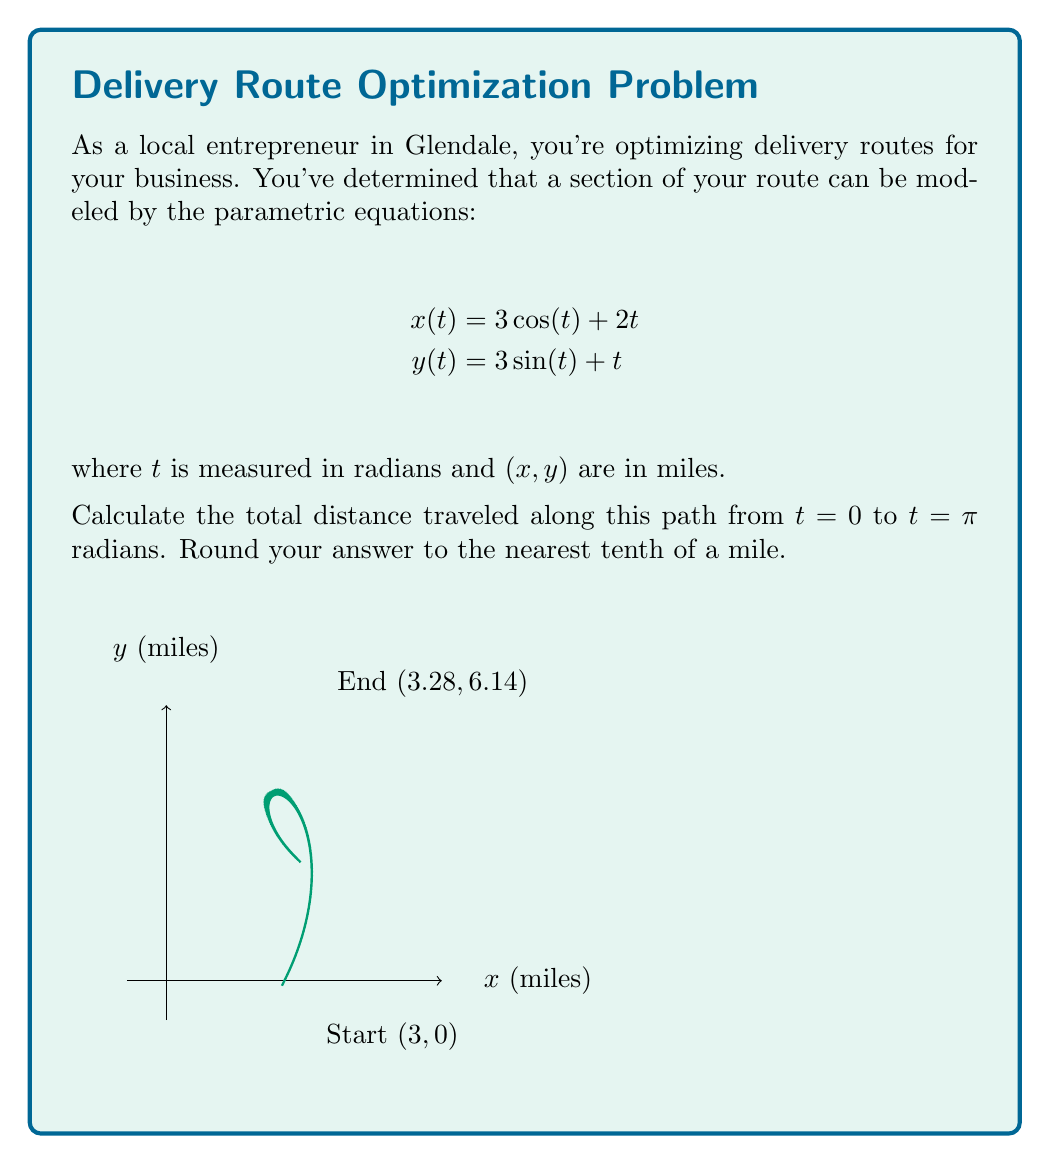Can you solve this math problem? To find the total distance traveled, we need to calculate the arc length of the parametric curve. The formula for arc length is:

$$L = \int_a^b \sqrt{\left(\frac{dx}{dt}\right)^2 + \left(\frac{dy}{dt}\right)^2} dt$$

Steps:
1) First, find $\frac{dx}{dt}$ and $\frac{dy}{dt}$:
   $$\frac{dx}{dt} = -3\sin(t) + 2$$
   $$\frac{dy}{dt} = 3\cos(t) + 1$$

2) Substitute these into the arc length formula:
   $$L = \int_0^\pi \sqrt{(-3\sin(t) + 2)^2 + (3\cos(t) + 1)^2} dt$$

3) Simplify under the square root:
   $$L = \int_0^\pi \sqrt{9\sin^2(t) - 12\sin(t) + 4 + 9\cos^2(t) + 6\cos(t) + 1} dt$$
   $$L = \int_0^\pi \sqrt{9(\sin^2(t) + \cos^2(t)) - 12\sin(t) + 6\cos(t) + 5} dt$$
   $$L = \int_0^\pi \sqrt{9 - 12\sin(t) + 6\cos(t) + 5} dt$$
   $$L = \int_0^\pi \sqrt{14 - 12\sin(t) + 6\cos(t)} dt$$

4) This integral cannot be solved analytically. We need to use numerical integration methods.

5) Using a computer algebra system or numerical integration tool, we can evaluate this integral:
   $$L \approx 6.5831$$

6) Rounding to the nearest tenth:
   $$L \approx 6.6 \text{ miles}$$
Answer: 6.6 miles 